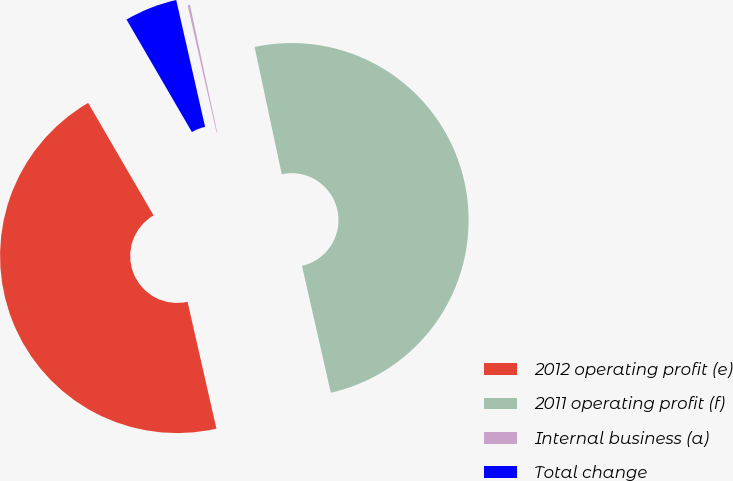<chart> <loc_0><loc_0><loc_500><loc_500><pie_chart><fcel>2012 operating profit (e)<fcel>2011 operating profit (f)<fcel>Internal business (a)<fcel>Total change<nl><fcel>45.18%<fcel>49.79%<fcel>0.21%<fcel>4.82%<nl></chart> 